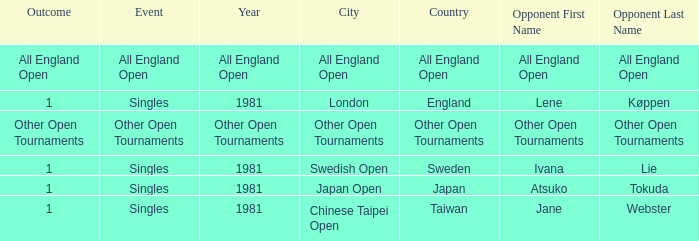What is the Outcome when All England Open is the Opponent in the final? All England Open. 